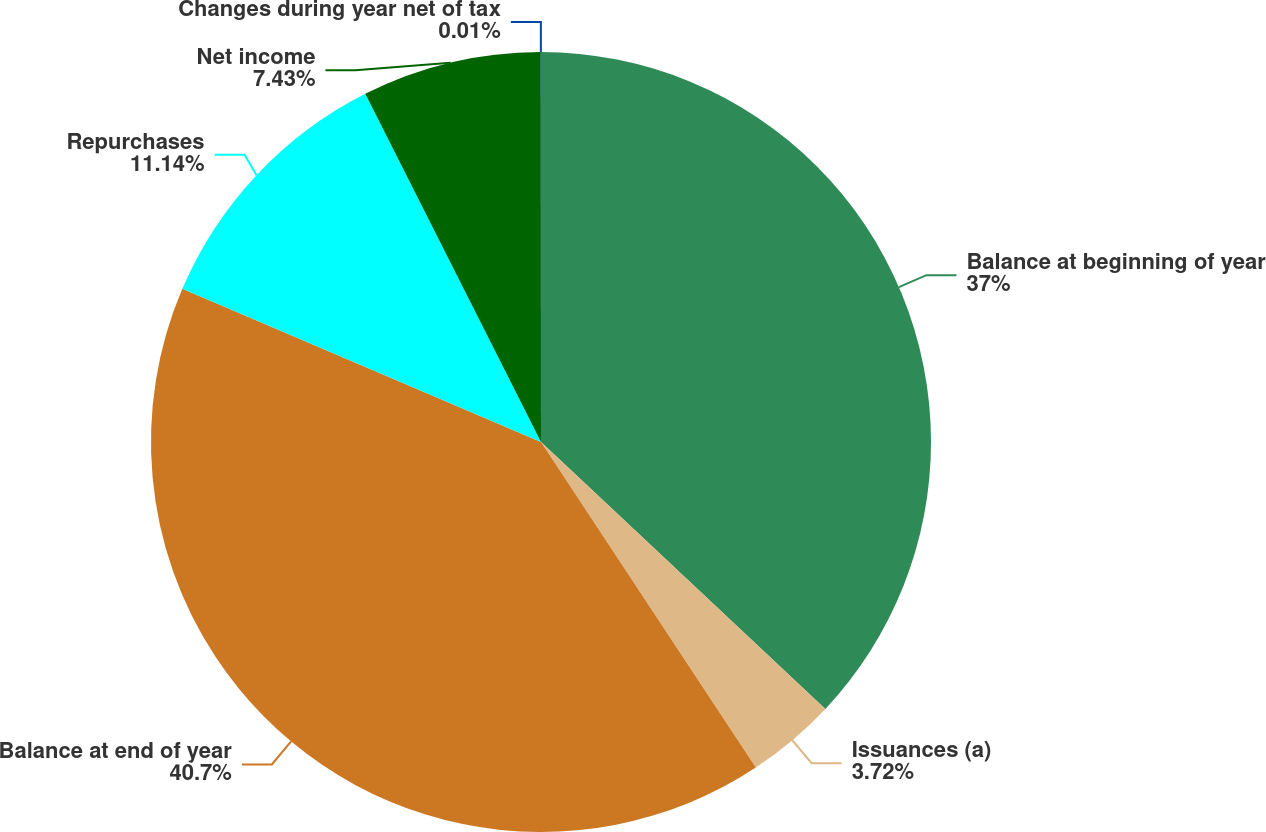Convert chart to OTSL. <chart><loc_0><loc_0><loc_500><loc_500><pie_chart><fcel>Balance at beginning of year<fcel>Issuances (a)<fcel>Balance at end of year<fcel>Repurchases<fcel>Net income<fcel>Changes during year net of tax<nl><fcel>37.0%<fcel>3.72%<fcel>40.71%<fcel>11.14%<fcel>7.43%<fcel>0.01%<nl></chart> 